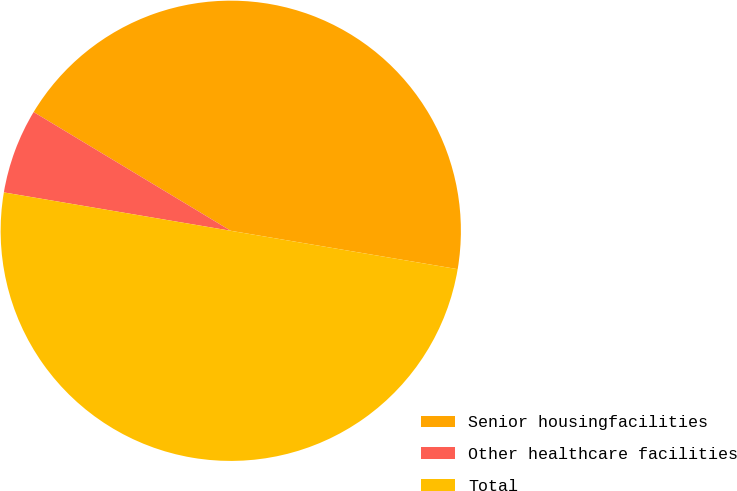<chart> <loc_0><loc_0><loc_500><loc_500><pie_chart><fcel>Senior housingfacilities<fcel>Other healthcare facilities<fcel>Total<nl><fcel>44.04%<fcel>5.96%<fcel>50.0%<nl></chart> 